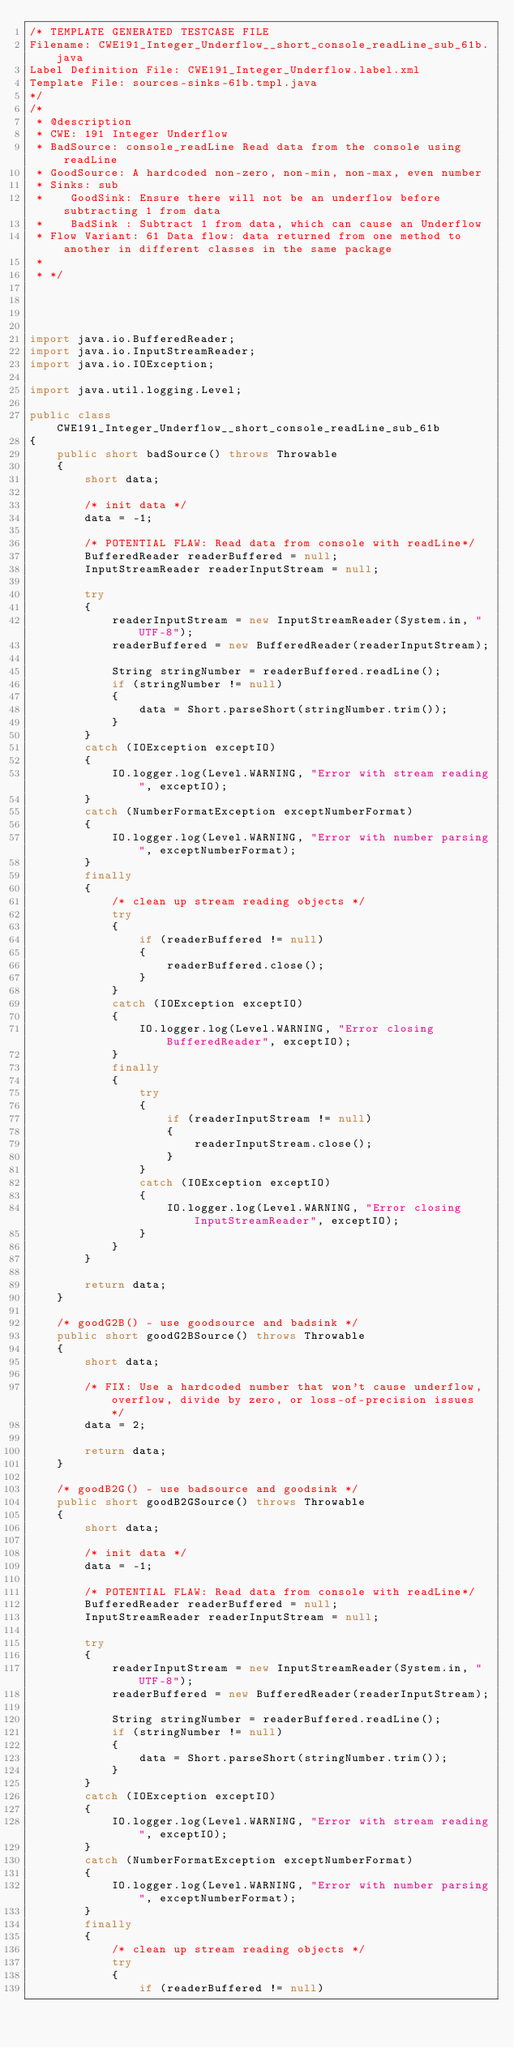<code> <loc_0><loc_0><loc_500><loc_500><_Java_>/* TEMPLATE GENERATED TESTCASE FILE
Filename: CWE191_Integer_Underflow__short_console_readLine_sub_61b.java
Label Definition File: CWE191_Integer_Underflow.label.xml
Template File: sources-sinks-61b.tmpl.java
*/
/*
 * @description
 * CWE: 191 Integer Underflow
 * BadSource: console_readLine Read data from the console using readLine
 * GoodSource: A hardcoded non-zero, non-min, non-max, even number
 * Sinks: sub
 *    GoodSink: Ensure there will not be an underflow before subtracting 1 from data
 *    BadSink : Subtract 1 from data, which can cause an Underflow
 * Flow Variant: 61 Data flow: data returned from one method to another in different classes in the same package
 *
 * */




import java.io.BufferedReader;
import java.io.InputStreamReader;
import java.io.IOException;

import java.util.logging.Level;

public class CWE191_Integer_Underflow__short_console_readLine_sub_61b
{
    public short badSource() throws Throwable
    {
        short data;

        /* init data */
        data = -1;

        /* POTENTIAL FLAW: Read data from console with readLine*/
        BufferedReader readerBuffered = null;
        InputStreamReader readerInputStream = null;

        try
        {
            readerInputStream = new InputStreamReader(System.in, "UTF-8");
            readerBuffered = new BufferedReader(readerInputStream);

            String stringNumber = readerBuffered.readLine();
            if (stringNumber != null)
            {
                data = Short.parseShort(stringNumber.trim());
            }
        }
        catch (IOException exceptIO)
        {
            IO.logger.log(Level.WARNING, "Error with stream reading", exceptIO);
        }
        catch (NumberFormatException exceptNumberFormat)
        {
            IO.logger.log(Level.WARNING, "Error with number parsing", exceptNumberFormat);
        }
        finally
        {
            /* clean up stream reading objects */
            try
            {
                if (readerBuffered != null)
                {
                    readerBuffered.close();
                }
            }
            catch (IOException exceptIO)
            {
                IO.logger.log(Level.WARNING, "Error closing BufferedReader", exceptIO);
            }
            finally
            {
                try
                {
                    if (readerInputStream != null)
                    {
                        readerInputStream.close();
                    }
                }
                catch (IOException exceptIO)
                {
                    IO.logger.log(Level.WARNING, "Error closing InputStreamReader", exceptIO);
                }
            }
        }

        return data;
    }

    /* goodG2B() - use goodsource and badsink */
    public short goodG2BSource() throws Throwable
    {
        short data;

        /* FIX: Use a hardcoded number that won't cause underflow, overflow, divide by zero, or loss-of-precision issues */
        data = 2;

        return data;
    }

    /* goodB2G() - use badsource and goodsink */
    public short goodB2GSource() throws Throwable
    {
        short data;

        /* init data */
        data = -1;

        /* POTENTIAL FLAW: Read data from console with readLine*/
        BufferedReader readerBuffered = null;
        InputStreamReader readerInputStream = null;

        try
        {
            readerInputStream = new InputStreamReader(System.in, "UTF-8");
            readerBuffered = new BufferedReader(readerInputStream);

            String stringNumber = readerBuffered.readLine();
            if (stringNumber != null)
            {
                data = Short.parseShort(stringNumber.trim());
            }
        }
        catch (IOException exceptIO)
        {
            IO.logger.log(Level.WARNING, "Error with stream reading", exceptIO);
        }
        catch (NumberFormatException exceptNumberFormat)
        {
            IO.logger.log(Level.WARNING, "Error with number parsing", exceptNumberFormat);
        }
        finally
        {
            /* clean up stream reading objects */
            try
            {
                if (readerBuffered != null)</code> 